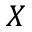Convert formula to latex. <formula><loc_0><loc_0><loc_500><loc_500>X</formula> 